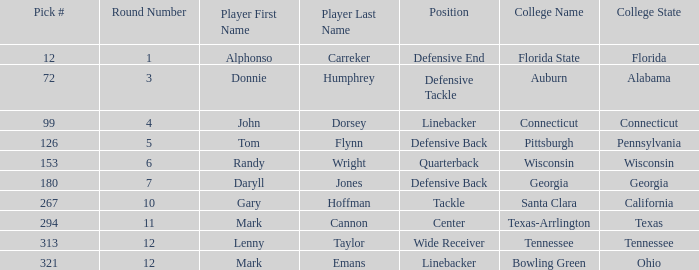What is the Position of Pick #321? Linebacker. 